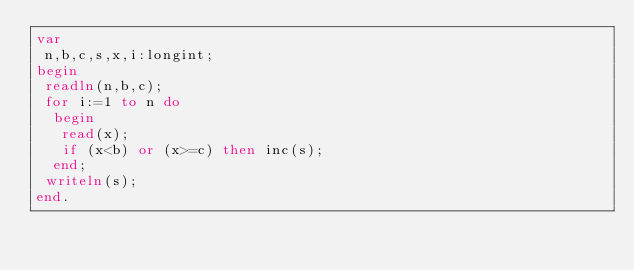<code> <loc_0><loc_0><loc_500><loc_500><_Pascal_>var
 n,b,c,s,x,i:longint;
begin
 readln(n,b,c);
 for i:=1 to n do
  begin
   read(x);
   if (x<b) or (x>=c) then inc(s);
  end;
 writeln(s);
end.</code> 